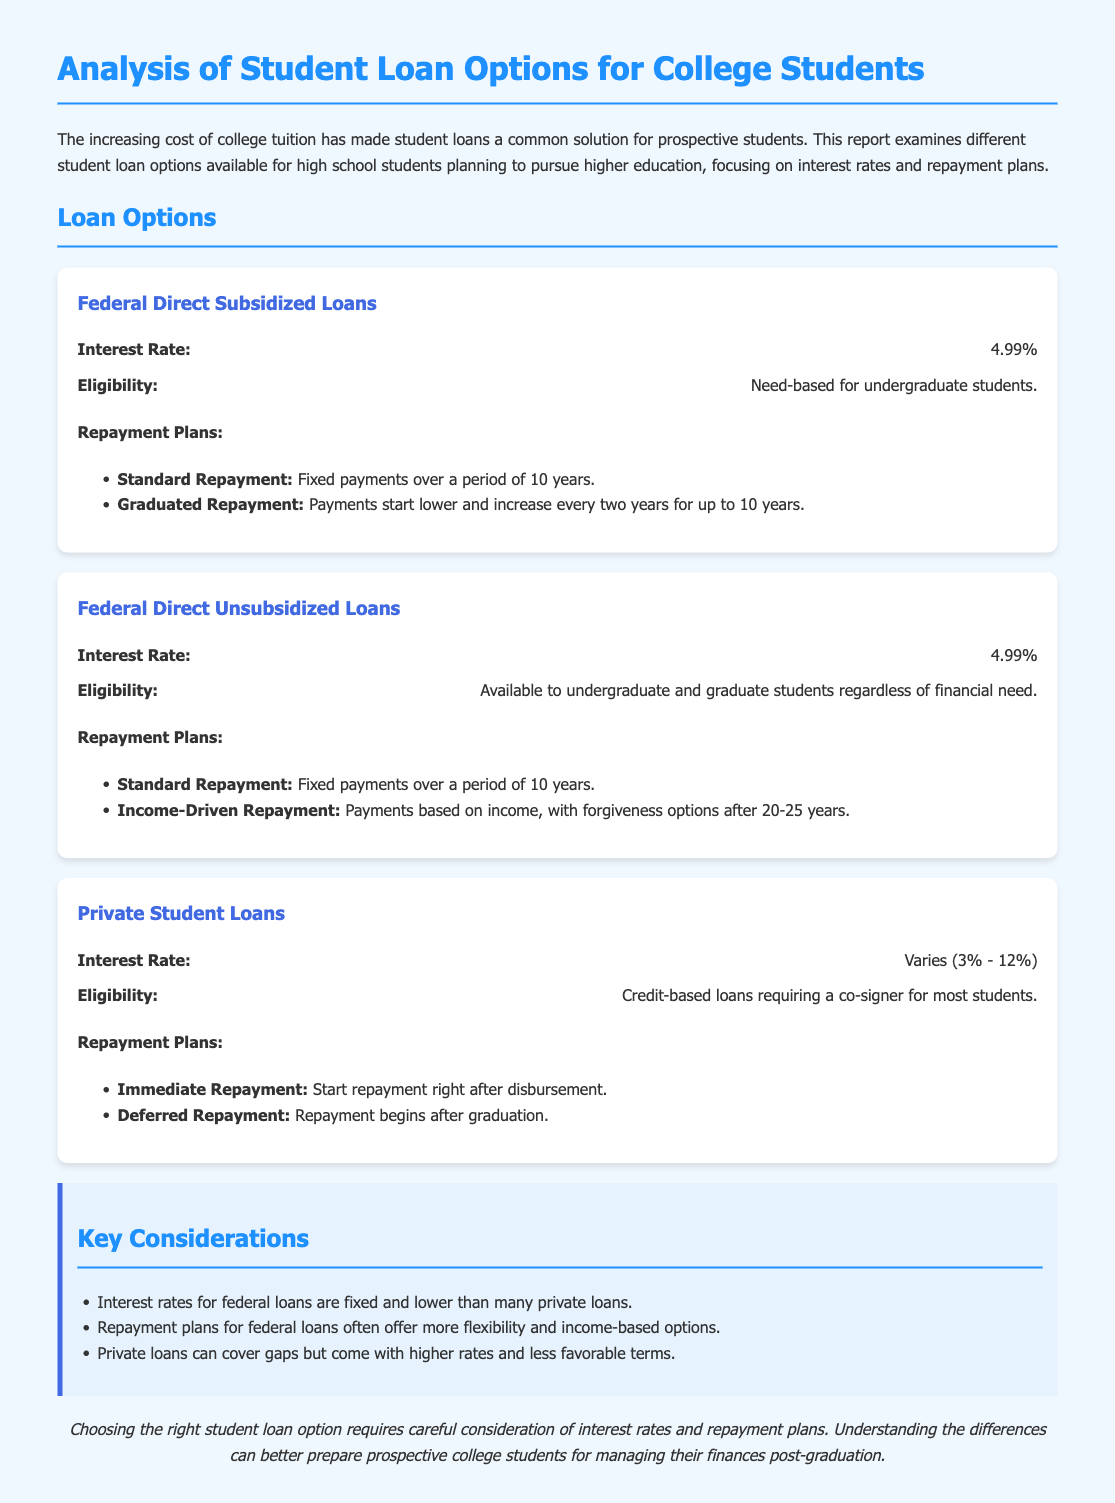What is the interest rate for Federal Direct Subsidized Loans? The interest rate is explicitly stated as 4.99% in the document.
Answer: 4.99% What are the eligibility requirements for Federal Direct Unsubsidized Loans? The document mentions that these loans are available to undergraduate and graduate students regardless of financial need.
Answer: Available regardless of financial need What is one repayment plan option for Private Student Loans? The document provides two repayment plan options and names "Immediate Repayment" as one.
Answer: Immediate Repayment What is the interest rate range for Private Student Loans? The document specifies that the interest rate for private loans varies between 3% and 12%.
Answer: 3% - 12% What is a key consideration regarding federal loans compared to private loans? The document states that interest rates for federal loans are fixed and lower than many private loans, making this a key consideration.
Answer: Lower rates What repayment plan offers flexibility based on income for Federal Direct Unsubsidized Loans? The document mentions "Income-Driven Repayment" as the repayment plan that adjusts based on income.
Answer: Income-Driven Repayment What is the repayment period for Standard Repayment on federal loans? The document clearly states that the repayment period for Standard Repayment is 10 years.
Answer: 10 years What type of loans require a co-signer for most students? The document specifies that Private Student Loans typically require a co-signer, making this the relevant type of loan.
Answer: Private Student Loans 